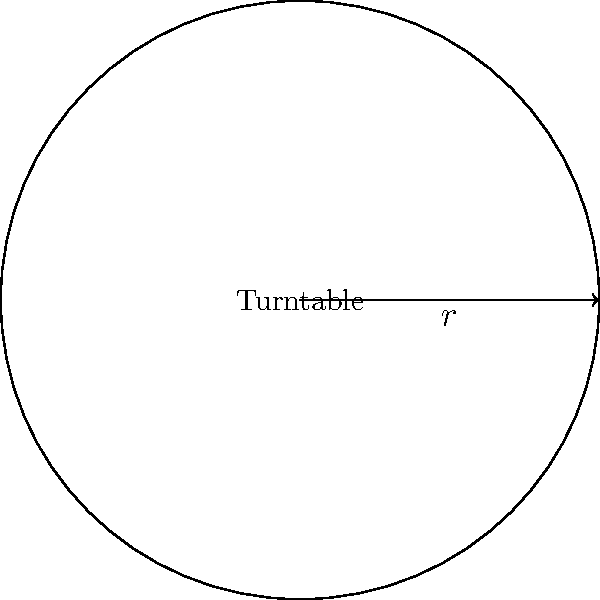As a producer, you're designing a new circular turntable for a live performance. If the radius of the turntable is 3 feet, what is the area of the turntable's surface in square feet? Round your answer to two decimal places. To find the area of a circular turntable, we need to use the formula for the area of a circle:

$$A = \pi r^2$$

Where:
$A$ = area of the circle
$\pi$ (pi) ≈ 3.14159
$r$ = radius of the circle

Given:
Radius ($r$) = 3 feet

Let's calculate:

1) Substitute the values into the formula:
   $$A = \pi \times 3^2$$

2) Calculate the square of the radius:
   $$A = \pi \times 9$$

3) Multiply by pi:
   $$A = 28.27431...$$

4) Round to two decimal places:
   $$A ≈ 28.27 \text{ square feet}$$

Therefore, the area of the turntable's surface is approximately 28.27 square feet.
Answer: 28.27 sq ft 